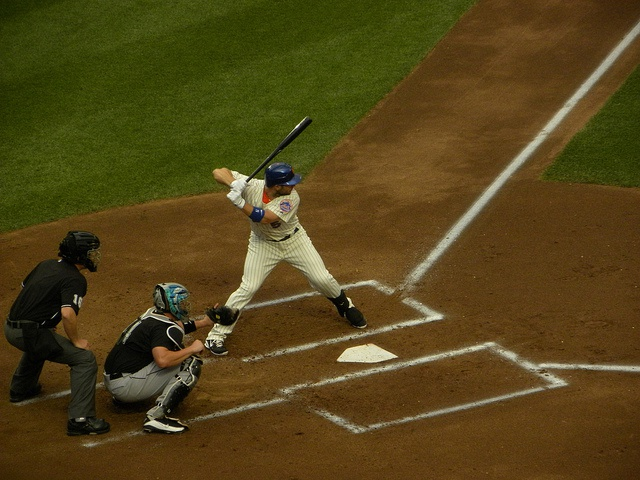Describe the objects in this image and their specific colors. I can see people in black, maroon, olive, and brown tones, people in black, gray, and olive tones, people in black, tan, and beige tones, baseball glove in black and olive tones, and baseball bat in black, gray, darkgreen, and olive tones in this image. 